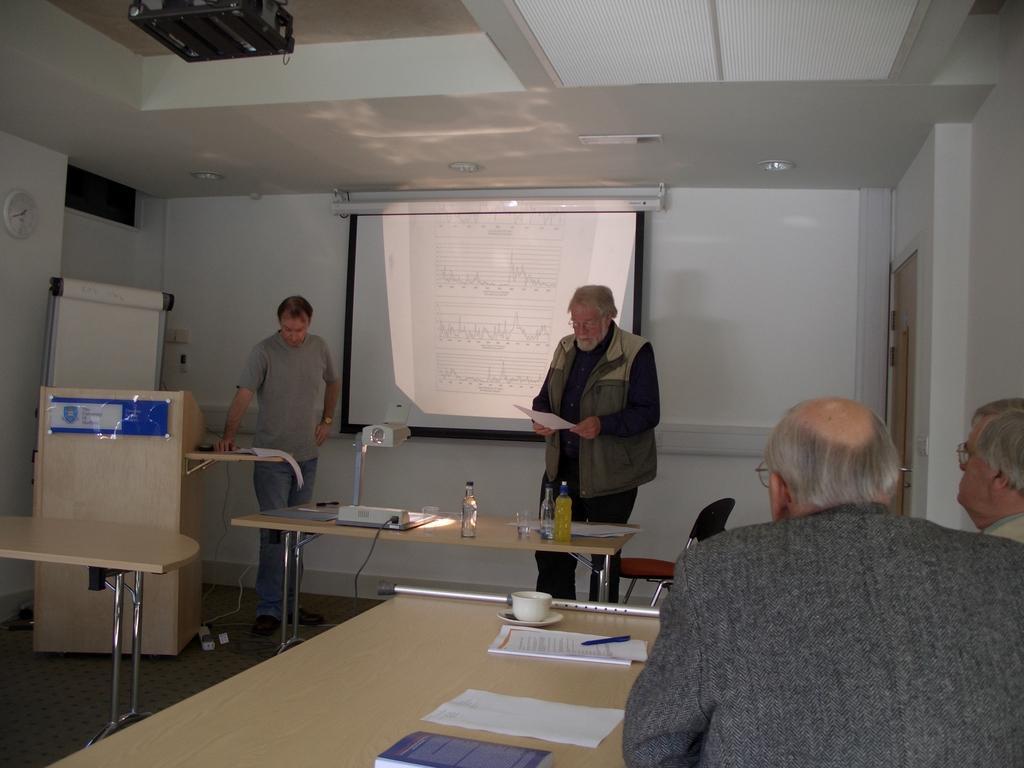Describe this image in one or two sentences. In the middle there is a man he wear jacket and trouser he is holding a paper. In the middle there is a table on that table there is a bottle and projector. on the left there is a man he is standing he wear t shirt and trouser. On the right there are two people staring at the screen. In the background there is a projector screen ,wall and door. 